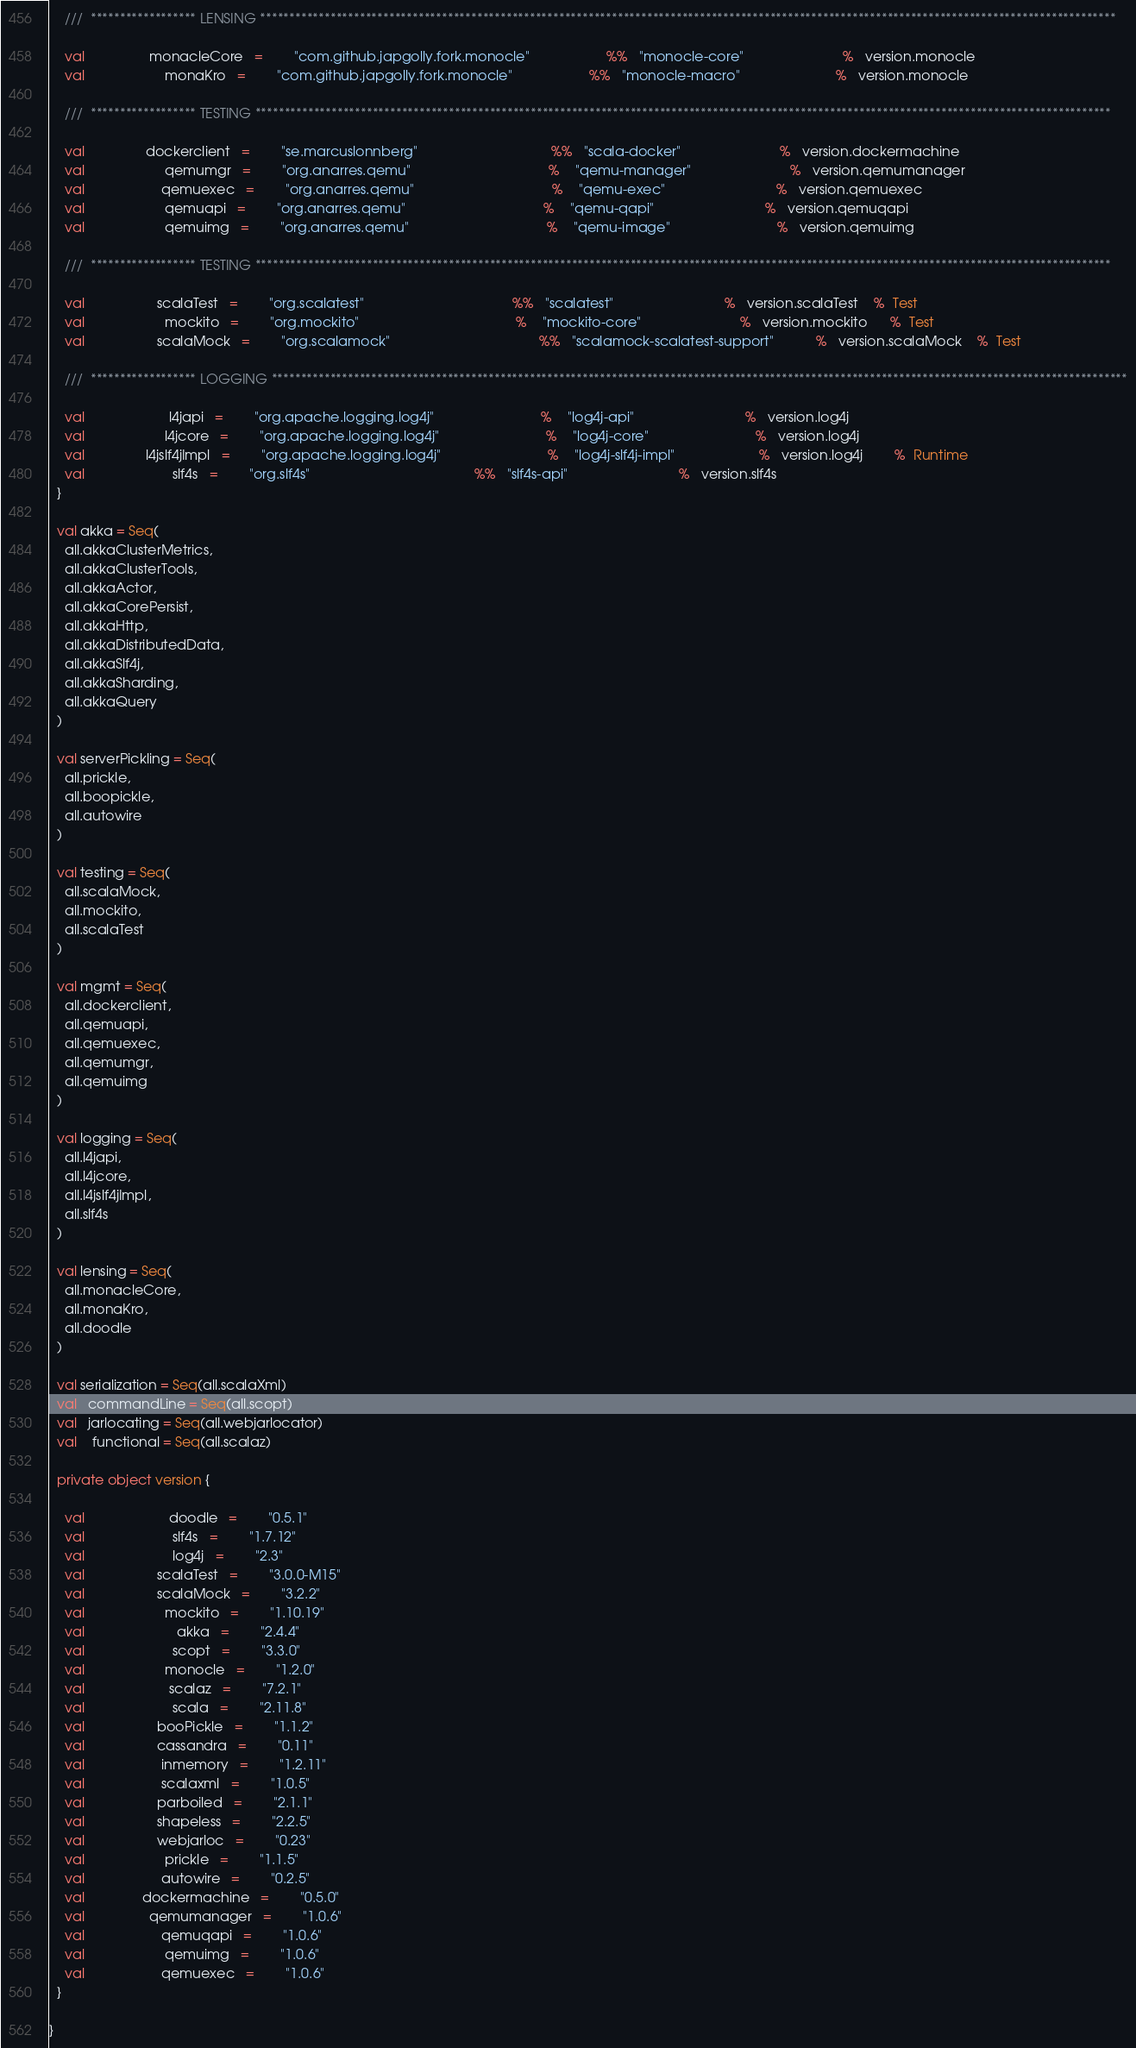Convert code to text. <code><loc_0><loc_0><loc_500><loc_500><_Scala_>
    ///  ****************** LENSING **************************************************************************************************************************************************

    val                 monacleCore   =        "com.github.japgolly.fork.monocle"                    %%   "monocle-core"                          %   version.monocle
    val                     monaKro   =        "com.github.japgolly.fork.monocle"                    %%   "monocle-macro"                         %   version.monocle

    ///  ****************** TESTING **************************************************************************************************************************************************

    val                dockerclient   =        "se.marcuslonnberg"                                   %%   "scala-docker"                          %   version.dockermachine
    val                     qemumgr   =        "org.anarres.qemu"                                    %    "qemu-manager"                          %   version.qemumanager
    val                    qemuexec   =        "org.anarres.qemu"                                    %    "qemu-exec"                             %   version.qemuexec
    val                     qemuapi   =        "org.anarres.qemu"                                    %    "qemu-qapi"                             %   version.qemuqapi
    val                     qemuimg   =        "org.anarres.qemu"                                    %    "qemu-image"                            %   version.qemuimg

    ///  ****************** TESTING **************************************************************************************************************************************************

    val                   scalaTest   =        "org.scalatest"                                       %%   "scalatest"                             %   version.scalaTest    %  Test
    val                     mockito   =        "org.mockito"                                         %    "mockito-core"                          %   version.mockito      %  Test
    val                   scalaMock   =        "org.scalamock"                                       %%   "scalamock-scalatest-support"           %   version.scalaMock    %  Test

    ///  ****************** LOGGING **************************************************************************************************************************************************

    val                      l4japi   =        "org.apache.logging.log4j"                            %    "log4j-api"                             %   version.log4j
    val                     l4jcore   =        "org.apache.logging.log4j"                            %    "log4j-core"                            %   version.log4j
    val                l4jslf4jImpl   =        "org.apache.logging.log4j"                            %    "log4j-slf4j-impl"                      %   version.log4j        %  Runtime
    val                       slf4s   =        "org.slf4s"                                           %%   "slf4s-api"                             %   version.slf4s
  }

  val akka = Seq(
    all.akkaClusterMetrics,
    all.akkaClusterTools,
    all.akkaActor,
    all.akkaCorePersist,
    all.akkaHttp,
    all.akkaDistributedData,
    all.akkaSlf4j,
    all.akkaSharding,
    all.akkaQuery
  )

  val serverPickling = Seq(
    all.prickle,
    all.boopickle,
    all.autowire
  )

  val testing = Seq(
    all.scalaMock,
    all.mockito,
    all.scalaTest
  )

  val mgmt = Seq(
    all.dockerclient,
    all.qemuapi,
    all.qemuexec,
    all.qemumgr,
    all.qemuimg
  )

  val logging = Seq(
    all.l4japi,
    all.l4jcore,
    all.l4jslf4jImpl,
    all.slf4s
  )

  val lensing = Seq(
    all.monacleCore,
    all.monaKro,
    all.doodle
  )

  val serialization = Seq(all.scalaXml)
  val   commandLine = Seq(all.scopt)
  val   jarlocating = Seq(all.webjarlocator)
  val    functional = Seq(all.scalaz)

  private object version {

    val                      doodle   =        "0.5.1"
    val                       slf4s   =        "1.7.12"
    val                       log4j   =        "2.3"
    val                   scalaTest   =        "3.0.0-M15"
    val                   scalaMock   =        "3.2.2"
    val                     mockito   =        "1.10.19"
    val                        akka   =        "2.4.4"
    val                       scopt   =        "3.3.0"
    val                     monocle   =        "1.2.0"
    val                      scalaz   =        "7.2.1"
    val                       scala   =        "2.11.8"
    val                   booPickle   =        "1.1.2"
    val                   cassandra   =        "0.11"
    val                    inmemory   =        "1.2.11"
    val                    scalaxml   =        "1.0.5"
    val                   parboiled   =        "2.1.1"
    val                   shapeless   =        "2.2.5"
    val                   webjarloc   =        "0.23"
    val                     prickle   =        "1.1.5"
    val                    autowire   =        "0.2.5"
    val               dockermachine   =        "0.5.0"
    val                 qemumanager   =        "1.0.6"
    val                    qemuqapi   =        "1.0.6"
    val                     qemuimg   =        "1.0.6"
    val                    qemuexec   =        "1.0.6"
  }

}</code> 